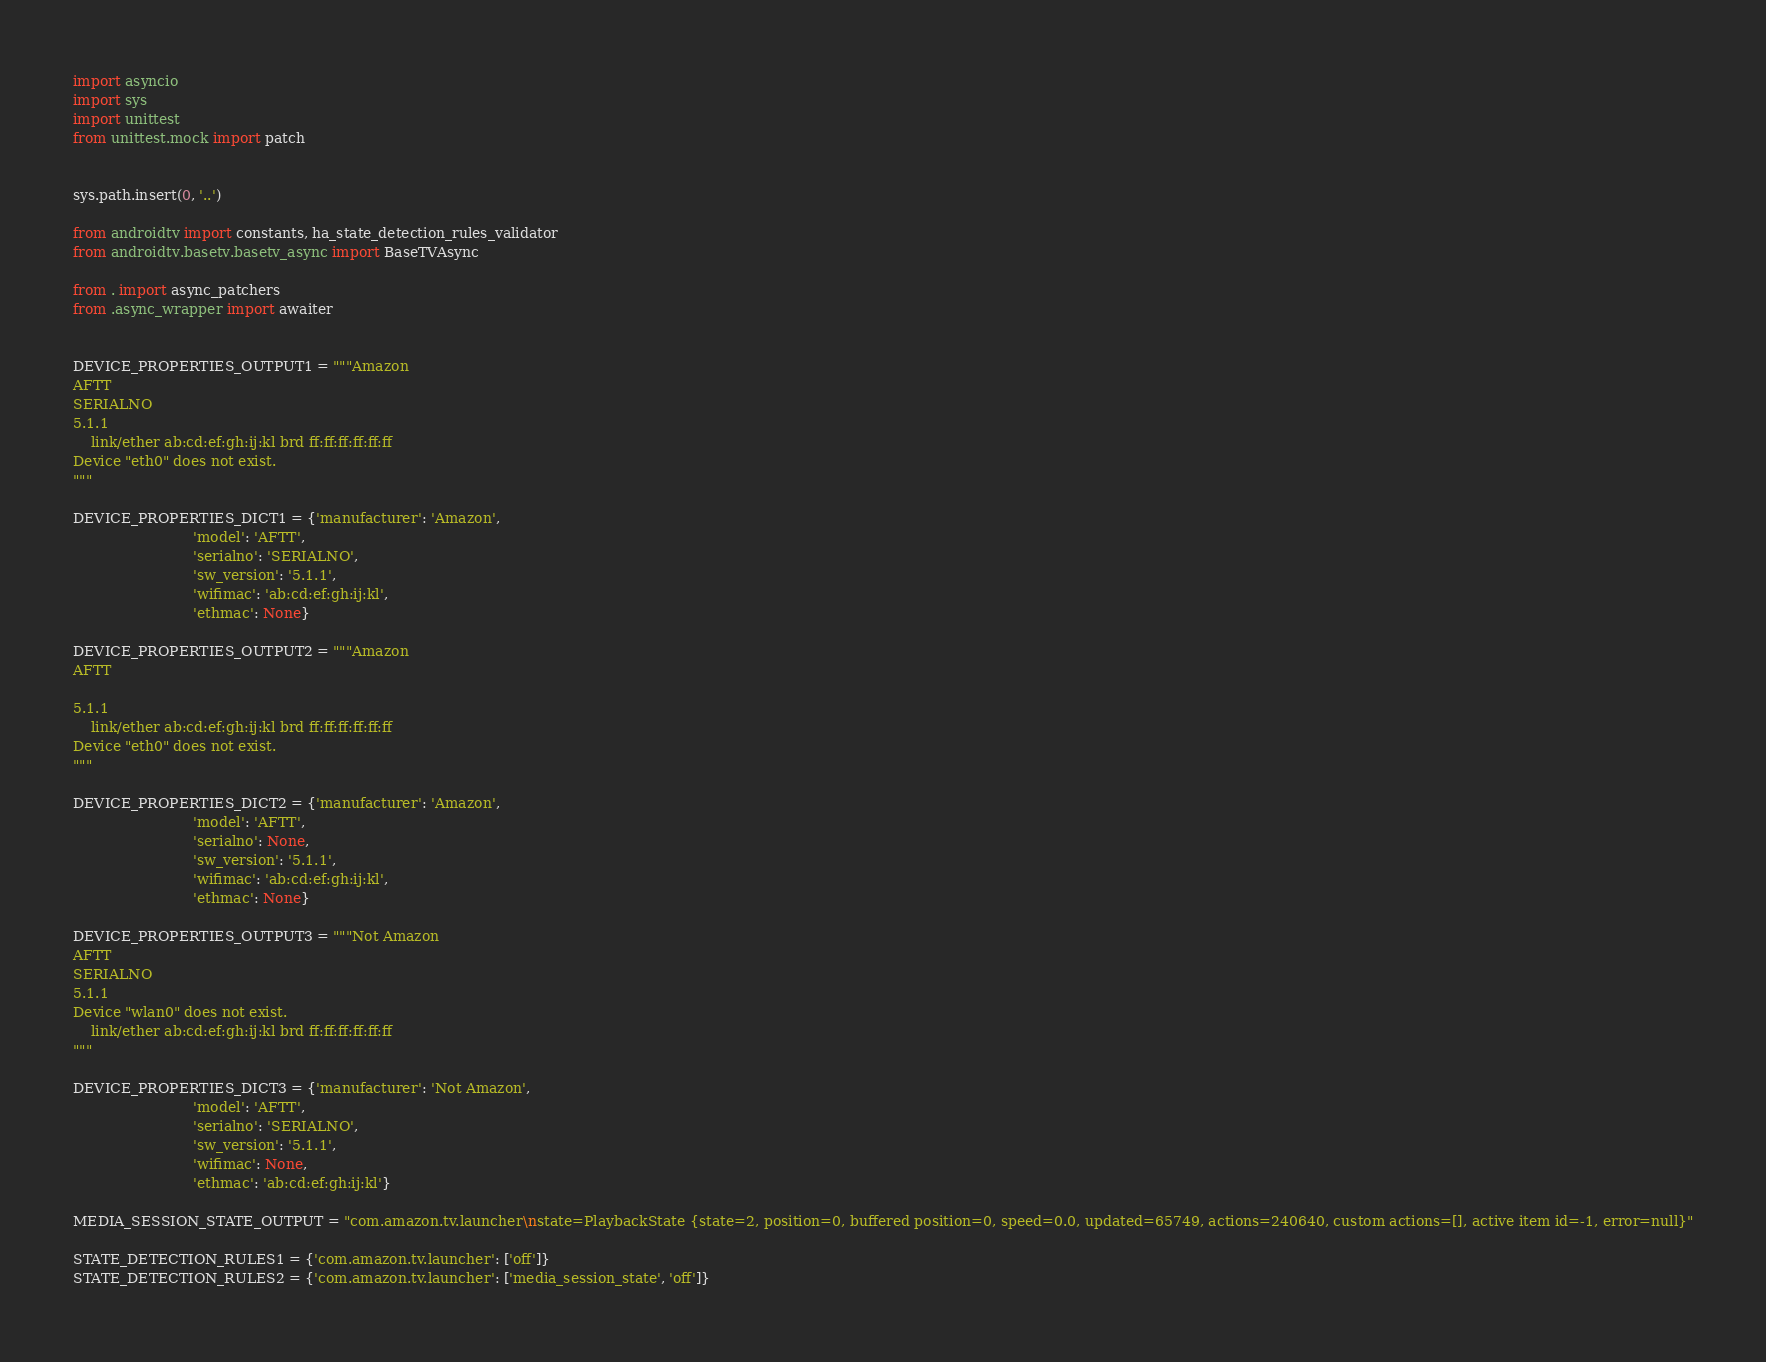Convert code to text. <code><loc_0><loc_0><loc_500><loc_500><_Python_>import asyncio
import sys
import unittest
from unittest.mock import patch


sys.path.insert(0, '..')

from androidtv import constants, ha_state_detection_rules_validator
from androidtv.basetv.basetv_async import BaseTVAsync

from . import async_patchers
from .async_wrapper import awaiter


DEVICE_PROPERTIES_OUTPUT1 = """Amazon
AFTT
SERIALNO
5.1.1
    link/ether ab:cd:ef:gh:ij:kl brd ff:ff:ff:ff:ff:ff
Device "eth0" does not exist.
"""

DEVICE_PROPERTIES_DICT1 = {'manufacturer': 'Amazon',
                           'model': 'AFTT',
                           'serialno': 'SERIALNO',
                           'sw_version': '5.1.1',
                           'wifimac': 'ab:cd:ef:gh:ij:kl',
                           'ethmac': None}

DEVICE_PROPERTIES_OUTPUT2 = """Amazon
AFTT
 
5.1.1
    link/ether ab:cd:ef:gh:ij:kl brd ff:ff:ff:ff:ff:ff
Device "eth0" does not exist.
"""

DEVICE_PROPERTIES_DICT2 = {'manufacturer': 'Amazon',
                           'model': 'AFTT',
                           'serialno': None,
                           'sw_version': '5.1.1',
                           'wifimac': 'ab:cd:ef:gh:ij:kl',
                           'ethmac': None}

DEVICE_PROPERTIES_OUTPUT3 = """Not Amazon
AFTT
SERIALNO
5.1.1
Device "wlan0" does not exist.
    link/ether ab:cd:ef:gh:ij:kl brd ff:ff:ff:ff:ff:ff
"""

DEVICE_PROPERTIES_DICT3 = {'manufacturer': 'Not Amazon',
                           'model': 'AFTT',
                           'serialno': 'SERIALNO',
                           'sw_version': '5.1.1',
                           'wifimac': None,
                           'ethmac': 'ab:cd:ef:gh:ij:kl'}

MEDIA_SESSION_STATE_OUTPUT = "com.amazon.tv.launcher\nstate=PlaybackState {state=2, position=0, buffered position=0, speed=0.0, updated=65749, actions=240640, custom actions=[], active item id=-1, error=null}"

STATE_DETECTION_RULES1 = {'com.amazon.tv.launcher': ['off']}
STATE_DETECTION_RULES2 = {'com.amazon.tv.launcher': ['media_session_state', 'off']}</code> 